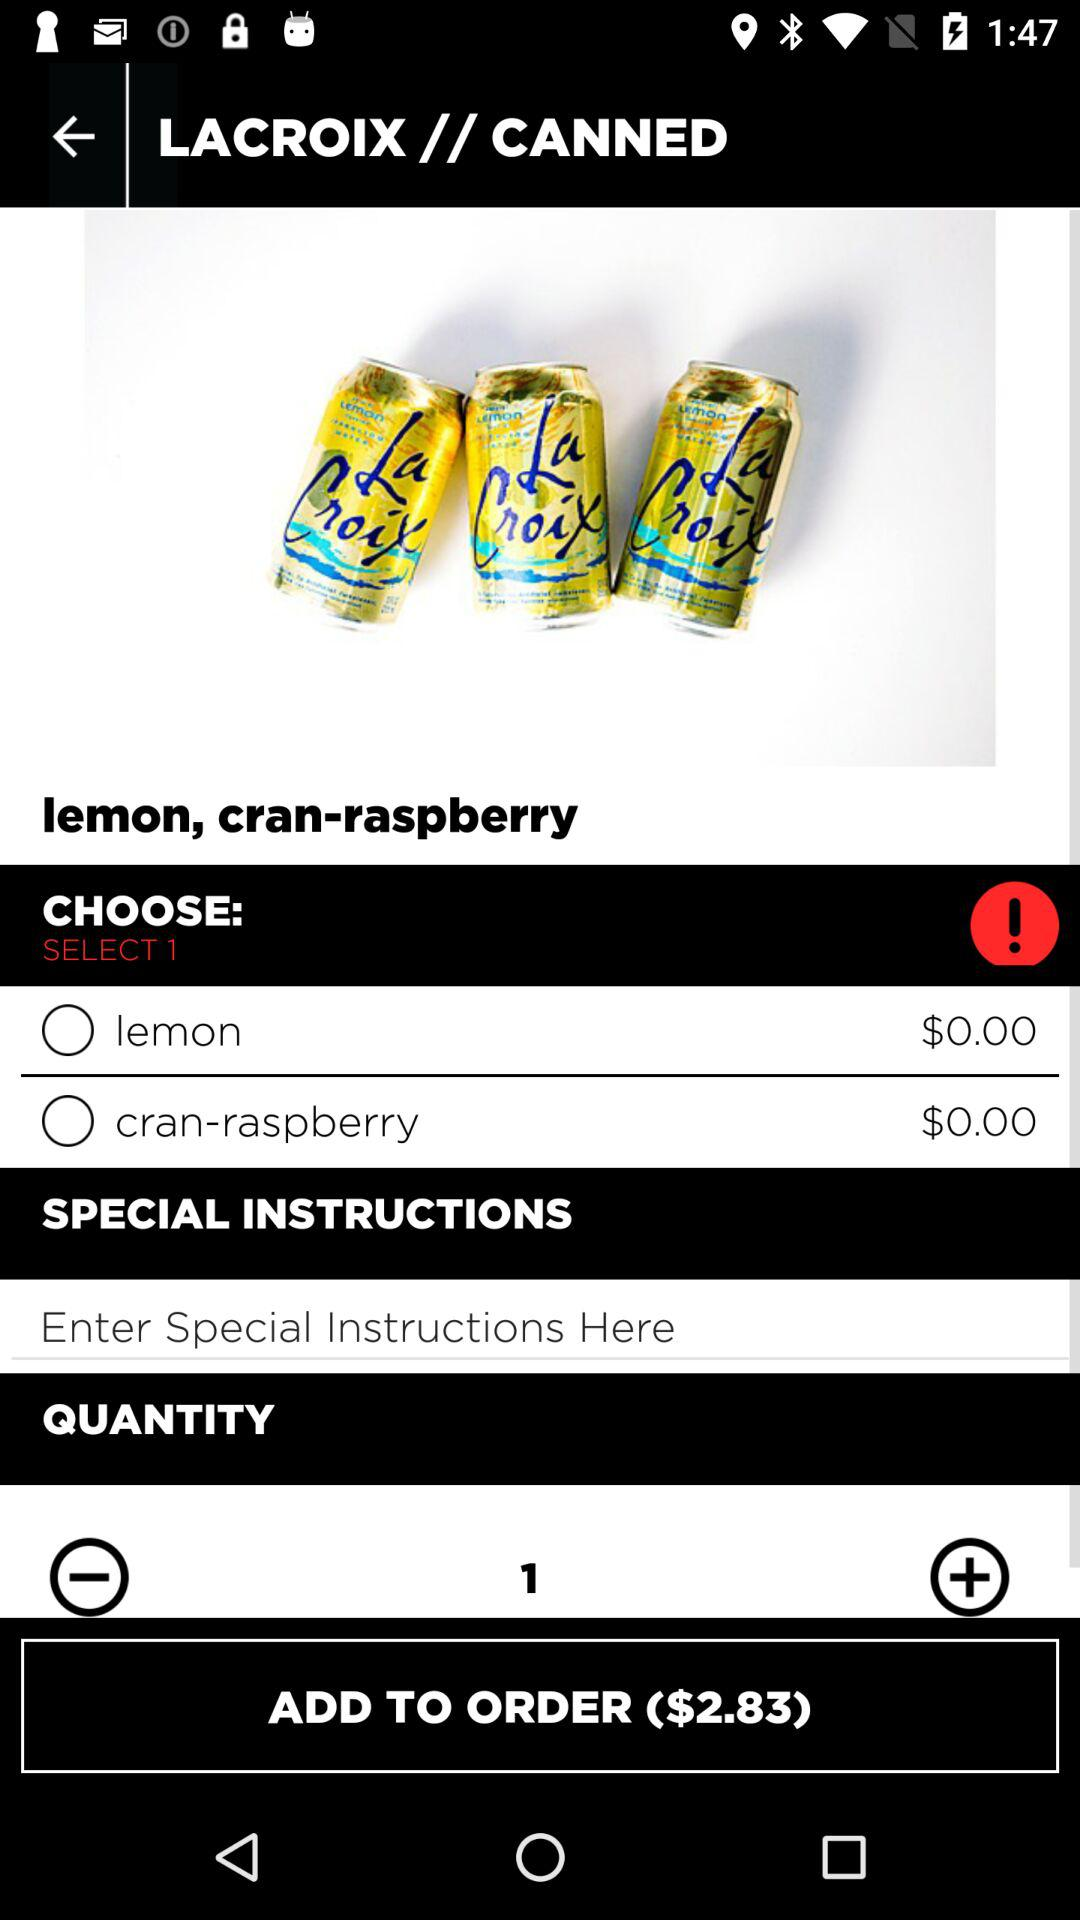What is the price of the lemon? The price of the lemon is $0.00. 